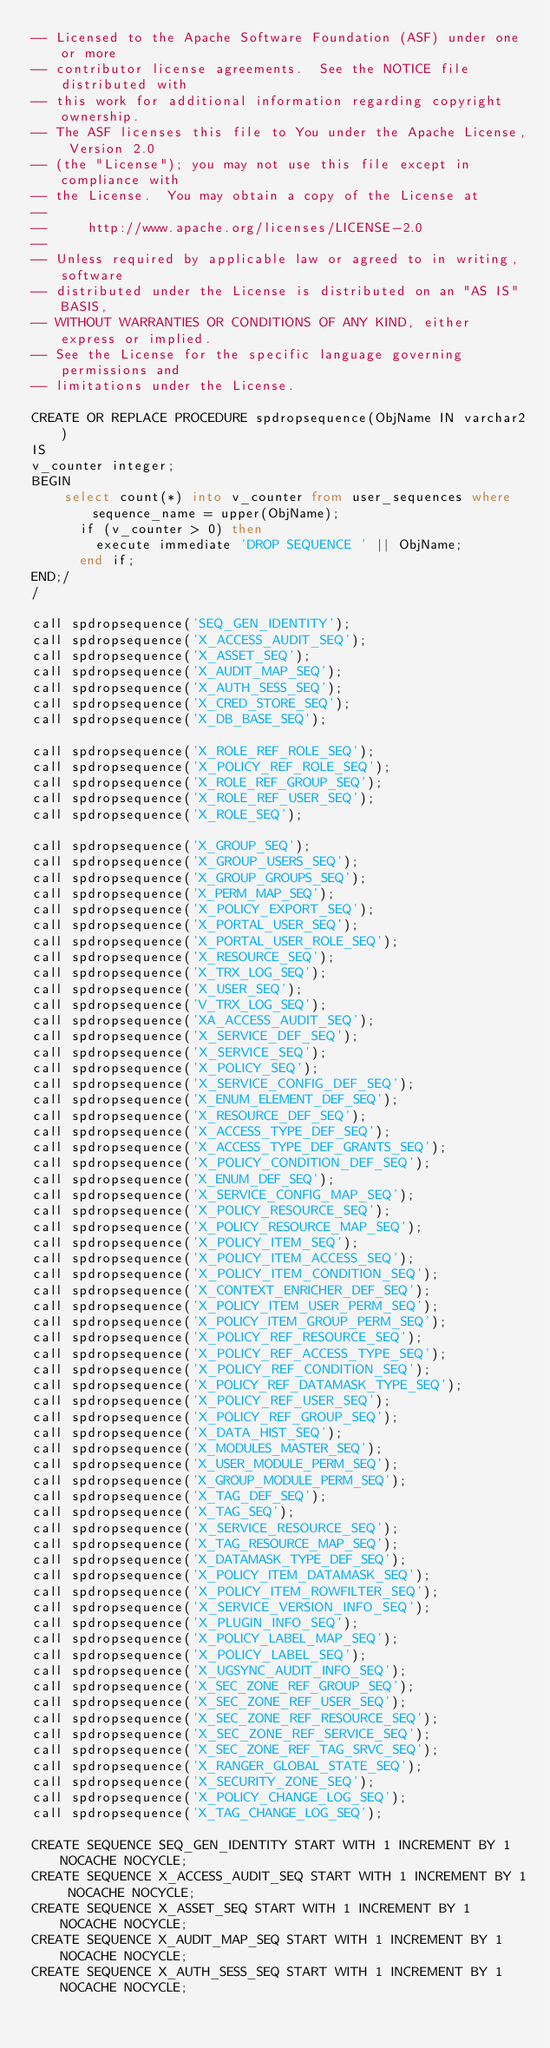<code> <loc_0><loc_0><loc_500><loc_500><_SQL_>-- Licensed to the Apache Software Foundation (ASF) under one or more
-- contributor license agreements.  See the NOTICE file distributed with
-- this work for additional information regarding copyright ownership.
-- The ASF licenses this file to You under the Apache License, Version 2.0
-- (the "License"); you may not use this file except in compliance with
-- the License.  You may obtain a copy of the License at
--
--     http://www.apache.org/licenses/LICENSE-2.0
--
-- Unless required by applicable law or agreed to in writing, software
-- distributed under the License is distributed on an "AS IS" BASIS,
-- WITHOUT WARRANTIES OR CONDITIONS OF ANY KIND, either express or implied.
-- See the License for the specific language governing permissions and
-- limitations under the License.

CREATE OR REPLACE PROCEDURE spdropsequence(ObjName IN varchar2)
IS
v_counter integer;
BEGIN
    select count(*) into v_counter from user_sequences where sequence_name = upper(ObjName);
      if (v_counter > 0) then
        execute immediate 'DROP SEQUENCE ' || ObjName;
      end if;
END;/
/

call spdropsequence('SEQ_GEN_IDENTITY');
call spdropsequence('X_ACCESS_AUDIT_SEQ');
call spdropsequence('X_ASSET_SEQ');
call spdropsequence('X_AUDIT_MAP_SEQ');
call spdropsequence('X_AUTH_SESS_SEQ');
call spdropsequence('X_CRED_STORE_SEQ');
call spdropsequence('X_DB_BASE_SEQ');

call spdropsequence('X_ROLE_REF_ROLE_SEQ');
call spdropsequence('X_POLICY_REF_ROLE_SEQ');
call spdropsequence('X_ROLE_REF_GROUP_SEQ');
call spdropsequence('X_ROLE_REF_USER_SEQ');
call spdropsequence('X_ROLE_SEQ');

call spdropsequence('X_GROUP_SEQ');
call spdropsequence('X_GROUP_USERS_SEQ');
call spdropsequence('X_GROUP_GROUPS_SEQ');
call spdropsequence('X_PERM_MAP_SEQ');
call spdropsequence('X_POLICY_EXPORT_SEQ');
call spdropsequence('X_PORTAL_USER_SEQ');
call spdropsequence('X_PORTAL_USER_ROLE_SEQ');
call spdropsequence('X_RESOURCE_SEQ');
call spdropsequence('X_TRX_LOG_SEQ');
call spdropsequence('X_USER_SEQ');
call spdropsequence('V_TRX_LOG_SEQ');
call spdropsequence('XA_ACCESS_AUDIT_SEQ');
call spdropsequence('X_SERVICE_DEF_SEQ');
call spdropsequence('X_SERVICE_SEQ');
call spdropsequence('X_POLICY_SEQ');
call spdropsequence('X_SERVICE_CONFIG_DEF_SEQ');
call spdropsequence('X_ENUM_ELEMENT_DEF_SEQ');
call spdropsequence('X_RESOURCE_DEF_SEQ');
call spdropsequence('X_ACCESS_TYPE_DEF_SEQ');
call spdropsequence('X_ACCESS_TYPE_DEF_GRANTS_SEQ');
call spdropsequence('X_POLICY_CONDITION_DEF_SEQ');
call spdropsequence('X_ENUM_DEF_SEQ');
call spdropsequence('X_SERVICE_CONFIG_MAP_SEQ');
call spdropsequence('X_POLICY_RESOURCE_SEQ');
call spdropsequence('X_POLICY_RESOURCE_MAP_SEQ');
call spdropsequence('X_POLICY_ITEM_SEQ');
call spdropsequence('X_POLICY_ITEM_ACCESS_SEQ');
call spdropsequence('X_POLICY_ITEM_CONDITION_SEQ');
call spdropsequence('X_CONTEXT_ENRICHER_DEF_SEQ');
call spdropsequence('X_POLICY_ITEM_USER_PERM_SEQ');
call spdropsequence('X_POLICY_ITEM_GROUP_PERM_SEQ');
call spdropsequence('X_POLICY_REF_RESOURCE_SEQ');
call spdropsequence('X_POLICY_REF_ACCESS_TYPE_SEQ');
call spdropsequence('X_POLICY_REF_CONDITION_SEQ');
call spdropsequence('X_POLICY_REF_DATAMASK_TYPE_SEQ');
call spdropsequence('X_POLICY_REF_USER_SEQ');
call spdropsequence('X_POLICY_REF_GROUP_SEQ');
call spdropsequence('X_DATA_HIST_SEQ');
call spdropsequence('X_MODULES_MASTER_SEQ');
call spdropsequence('X_USER_MODULE_PERM_SEQ');
call spdropsequence('X_GROUP_MODULE_PERM_SEQ');
call spdropsequence('X_TAG_DEF_SEQ');
call spdropsequence('X_TAG_SEQ');
call spdropsequence('X_SERVICE_RESOURCE_SEQ');
call spdropsequence('X_TAG_RESOURCE_MAP_SEQ');
call spdropsequence('X_DATAMASK_TYPE_DEF_SEQ');
call spdropsequence('X_POLICY_ITEM_DATAMASK_SEQ');
call spdropsequence('X_POLICY_ITEM_ROWFILTER_SEQ');
call spdropsequence('X_SERVICE_VERSION_INFO_SEQ');
call spdropsequence('X_PLUGIN_INFO_SEQ');
call spdropsequence('X_POLICY_LABEL_MAP_SEQ');
call spdropsequence('X_POLICY_LABEL_SEQ');
call spdropsequence('X_UGSYNC_AUDIT_INFO_SEQ');
call spdropsequence('X_SEC_ZONE_REF_GROUP_SEQ');
call spdropsequence('X_SEC_ZONE_REF_USER_SEQ');
call spdropsequence('X_SEC_ZONE_REF_RESOURCE_SEQ');
call spdropsequence('X_SEC_ZONE_REF_SERVICE_SEQ');
call spdropsequence('X_SEC_ZONE_REF_TAG_SRVC_SEQ');
call spdropsequence('X_RANGER_GLOBAL_STATE_SEQ');
call spdropsequence('X_SECURITY_ZONE_SEQ');
call spdropsequence('X_POLICY_CHANGE_LOG_SEQ');
call spdropsequence('X_TAG_CHANGE_LOG_SEQ');

CREATE SEQUENCE SEQ_GEN_IDENTITY START WITH 1 INCREMENT BY 1 NOCACHE NOCYCLE;
CREATE SEQUENCE X_ACCESS_AUDIT_SEQ START WITH 1 INCREMENT BY 1 NOCACHE NOCYCLE;
CREATE SEQUENCE X_ASSET_SEQ START WITH 1 INCREMENT BY 1 NOCACHE NOCYCLE;
CREATE SEQUENCE X_AUDIT_MAP_SEQ START WITH 1 INCREMENT BY 1 NOCACHE NOCYCLE;
CREATE SEQUENCE X_AUTH_SESS_SEQ START WITH 1 INCREMENT BY 1 NOCACHE NOCYCLE;</code> 